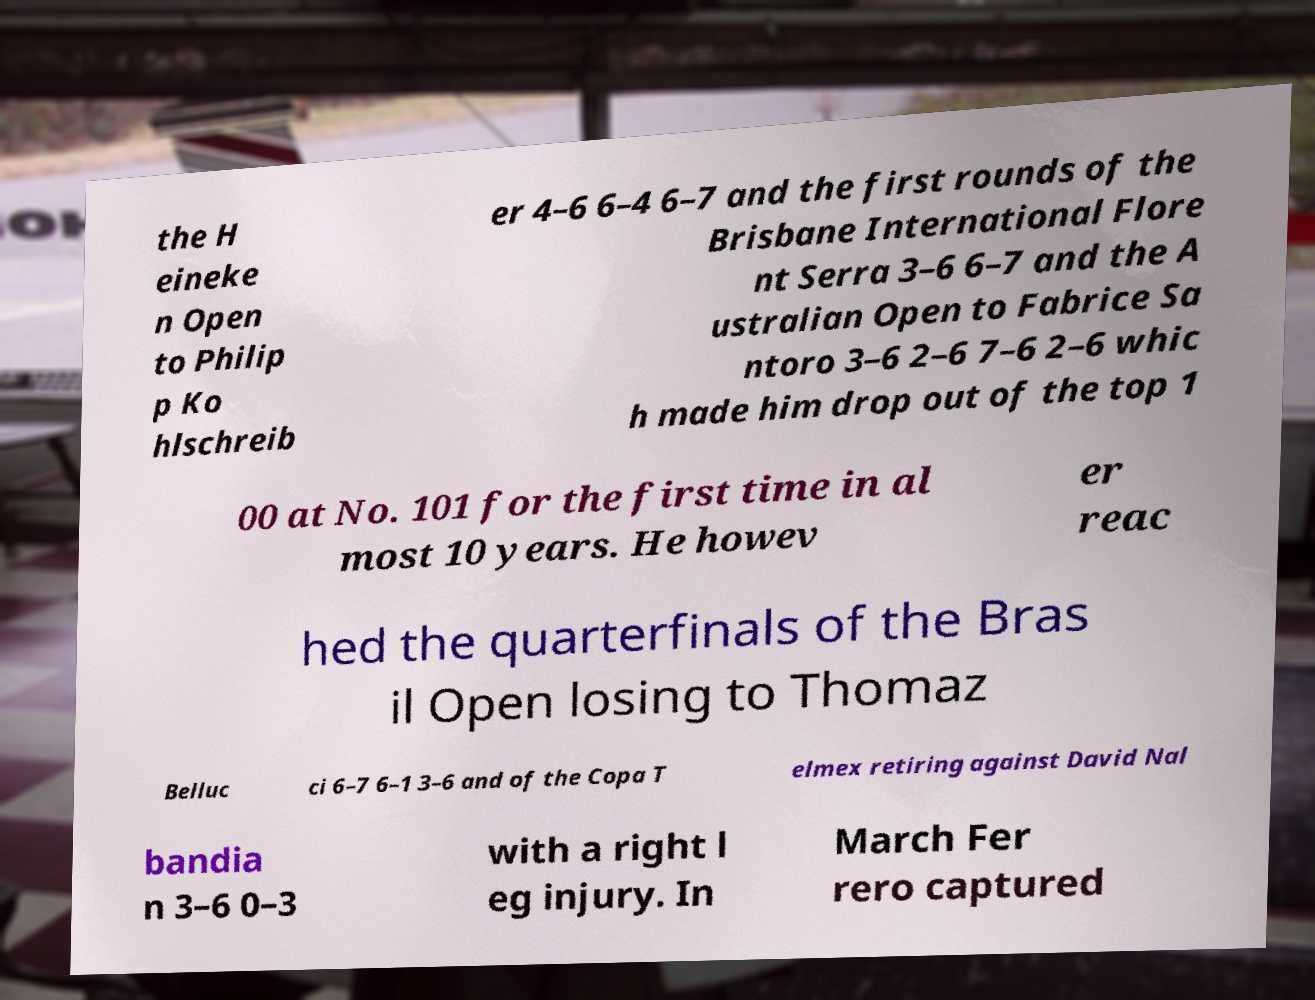Could you extract and type out the text from this image? the H eineke n Open to Philip p Ko hlschreib er 4–6 6–4 6–7 and the first rounds of the Brisbane International Flore nt Serra 3–6 6–7 and the A ustralian Open to Fabrice Sa ntoro 3–6 2–6 7–6 2–6 whic h made him drop out of the top 1 00 at No. 101 for the first time in al most 10 years. He howev er reac hed the quarterfinals of the Bras il Open losing to Thomaz Belluc ci 6–7 6–1 3–6 and of the Copa T elmex retiring against David Nal bandia n 3–6 0–3 with a right l eg injury. In March Fer rero captured 